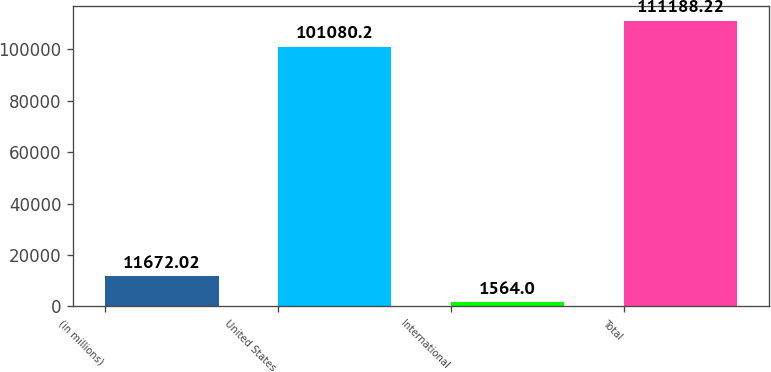<chart> <loc_0><loc_0><loc_500><loc_500><bar_chart><fcel>(in millions)<fcel>United States<fcel>International<fcel>Total<nl><fcel>11672<fcel>101080<fcel>1564<fcel>111188<nl></chart> 